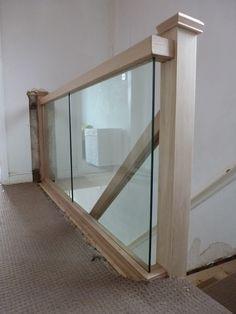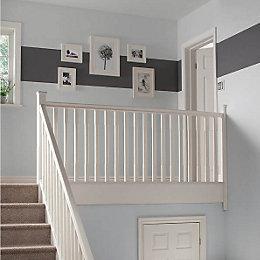The first image is the image on the left, the second image is the image on the right. For the images shown, is this caption "One image taken on an upper floor shows a brown wood handrail with vertical 'spindles' that goes around at least one side of a stairwell." true? Answer yes or no. No. The first image is the image on the left, the second image is the image on the right. Assess this claim about the two images: "Part of the stairway railing is made of glass.". Correct or not? Answer yes or no. Yes. 